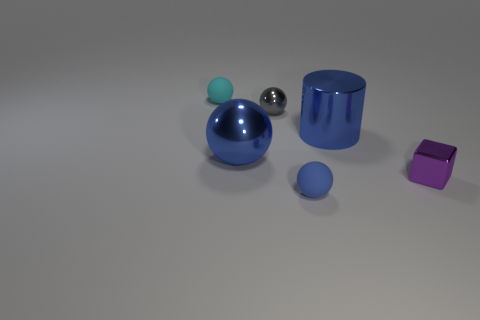Subtract all big blue balls. How many balls are left? 3 Add 1 blue rubber balls. How many objects exist? 7 Subtract all blue spheres. How many spheres are left? 2 Subtract 1 cylinders. How many cylinders are left? 0 Add 2 small cyan objects. How many small cyan objects exist? 3 Subtract 0 brown balls. How many objects are left? 6 Subtract all cylinders. How many objects are left? 5 Subtract all red cylinders. Subtract all red blocks. How many cylinders are left? 1 Subtract all yellow cylinders. How many yellow spheres are left? 0 Subtract all gray things. Subtract all blue spheres. How many objects are left? 3 